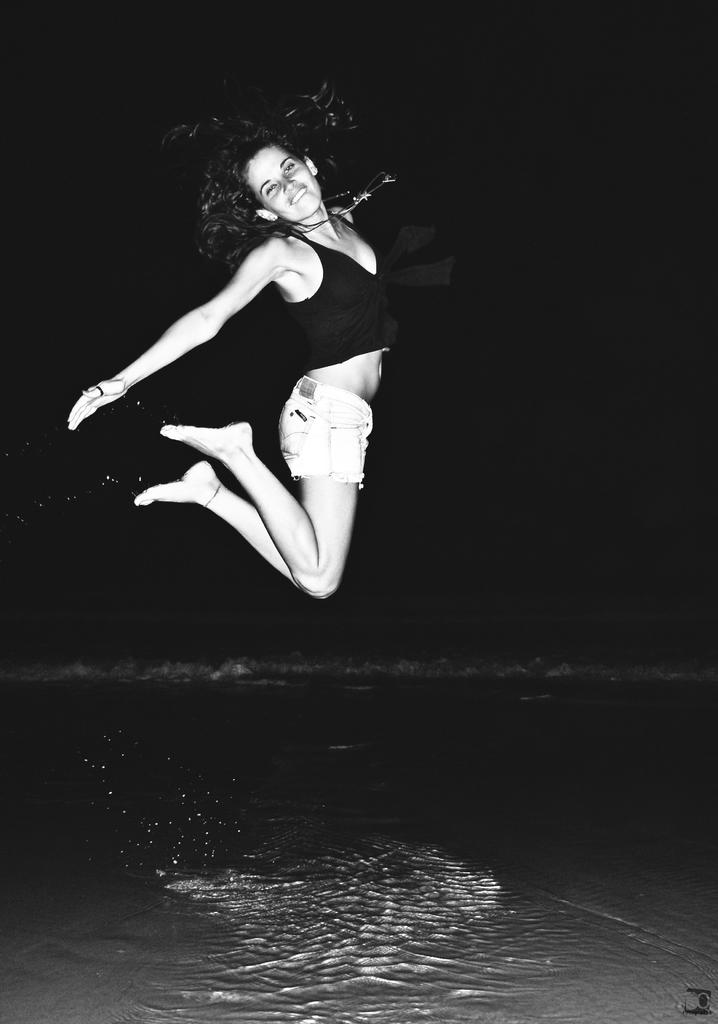What is the main subject of the image? The main subject of the image is a woman. What is the woman doing in the image? The woman is jumping from the water surface. How many times does the woman bite her hand in the image? There is no indication in the image that the woman is biting her hand, so it cannot be determined from the picture. 